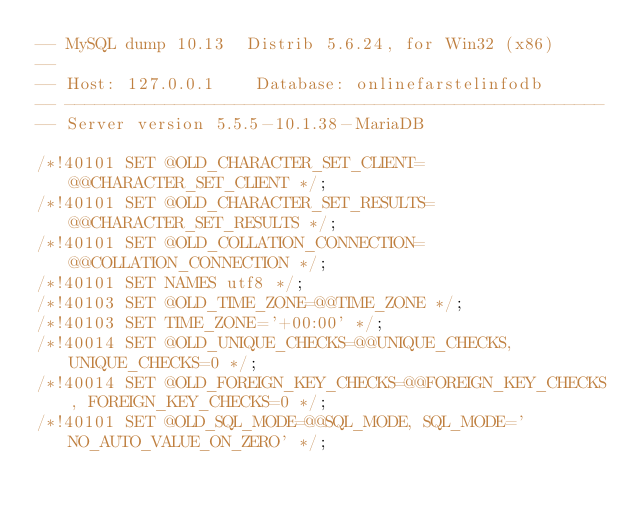Convert code to text. <code><loc_0><loc_0><loc_500><loc_500><_SQL_>-- MySQL dump 10.13  Distrib 5.6.24, for Win32 (x86)
--
-- Host: 127.0.0.1    Database: onlinefarstelinfodb
-- ------------------------------------------------------
-- Server version	5.5.5-10.1.38-MariaDB

/*!40101 SET @OLD_CHARACTER_SET_CLIENT=@@CHARACTER_SET_CLIENT */;
/*!40101 SET @OLD_CHARACTER_SET_RESULTS=@@CHARACTER_SET_RESULTS */;
/*!40101 SET @OLD_COLLATION_CONNECTION=@@COLLATION_CONNECTION */;
/*!40101 SET NAMES utf8 */;
/*!40103 SET @OLD_TIME_ZONE=@@TIME_ZONE */;
/*!40103 SET TIME_ZONE='+00:00' */;
/*!40014 SET @OLD_UNIQUE_CHECKS=@@UNIQUE_CHECKS, UNIQUE_CHECKS=0 */;
/*!40014 SET @OLD_FOREIGN_KEY_CHECKS=@@FOREIGN_KEY_CHECKS, FOREIGN_KEY_CHECKS=0 */;
/*!40101 SET @OLD_SQL_MODE=@@SQL_MODE, SQL_MODE='NO_AUTO_VALUE_ON_ZERO' */;</code> 